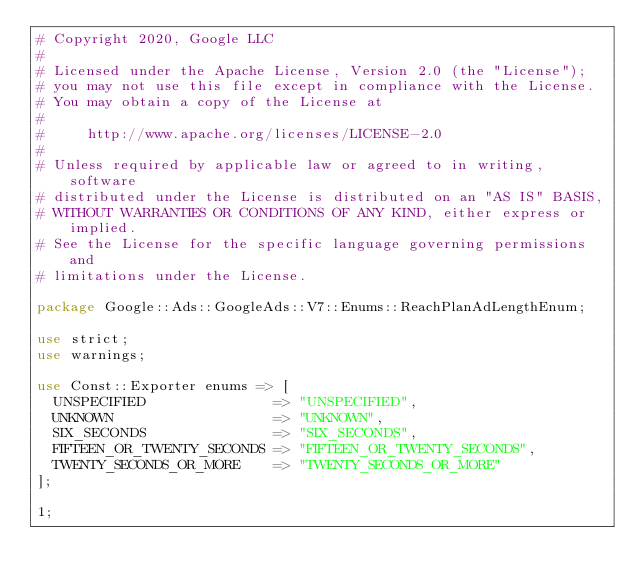Convert code to text. <code><loc_0><loc_0><loc_500><loc_500><_Perl_># Copyright 2020, Google LLC
#
# Licensed under the Apache License, Version 2.0 (the "License");
# you may not use this file except in compliance with the License.
# You may obtain a copy of the License at
#
#     http://www.apache.org/licenses/LICENSE-2.0
#
# Unless required by applicable law or agreed to in writing, software
# distributed under the License is distributed on an "AS IS" BASIS,
# WITHOUT WARRANTIES OR CONDITIONS OF ANY KIND, either express or implied.
# See the License for the specific language governing permissions and
# limitations under the License.

package Google::Ads::GoogleAds::V7::Enums::ReachPlanAdLengthEnum;

use strict;
use warnings;

use Const::Exporter enums => [
  UNSPECIFIED               => "UNSPECIFIED",
  UNKNOWN                   => "UNKNOWN",
  SIX_SECONDS               => "SIX_SECONDS",
  FIFTEEN_OR_TWENTY_SECONDS => "FIFTEEN_OR_TWENTY_SECONDS",
  TWENTY_SECONDS_OR_MORE    => "TWENTY_SECONDS_OR_MORE"
];

1;
</code> 